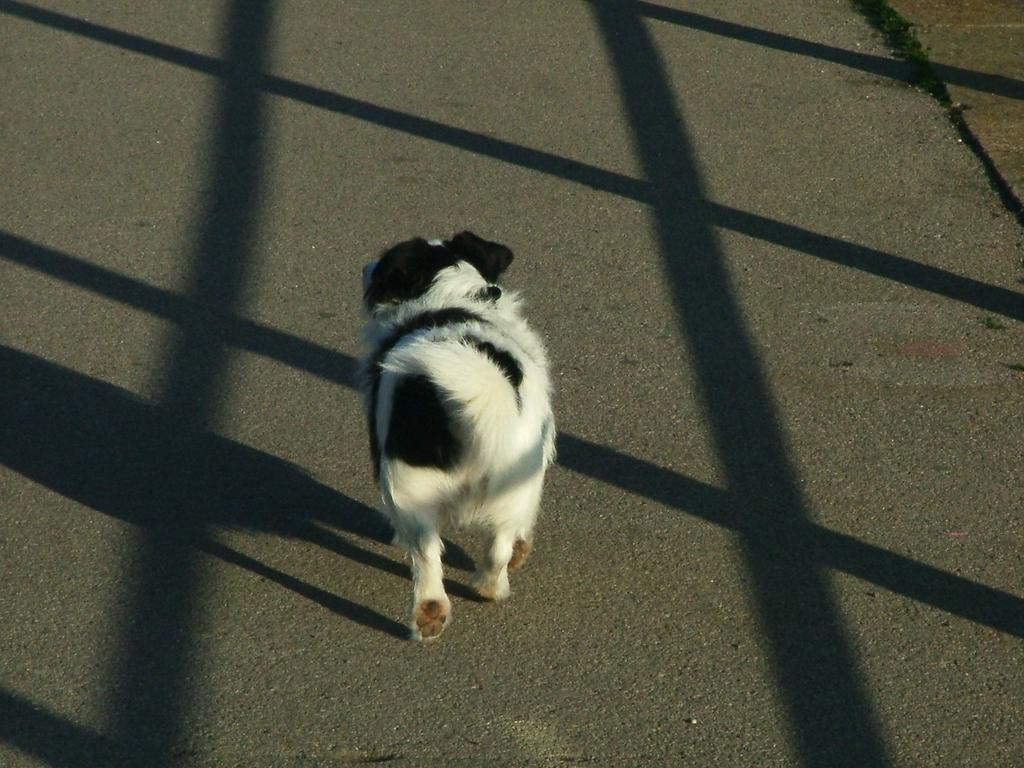What type of animal is present in the image? There is a dog in the image. What colors can be seen on the dog? The dog is black and white in color. What is the dog doing in the image? The dog is walking on the road. What else can be seen on the road in the image? There are shadows of poles on the road. Can you tell me what sense the woman is using to interact with the sink in the image? There is no woman or sink present in the image; it features a dog walking on the road. 